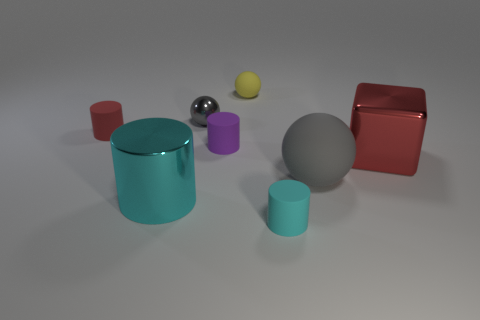Subtract all shiny cylinders. How many cylinders are left? 3 Subtract all red cylinders. How many cylinders are left? 3 Subtract all blue cylinders. Subtract all cyan balls. How many cylinders are left? 4 Add 1 yellow things. How many objects exist? 9 Subtract 0 green blocks. How many objects are left? 8 Subtract all blocks. How many objects are left? 7 Subtract all blue shiny things. Subtract all small cylinders. How many objects are left? 5 Add 5 matte balls. How many matte balls are left? 7 Add 6 small yellow balls. How many small yellow balls exist? 7 